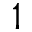<formula> <loc_0><loc_0><loc_500><loc_500>1</formula> 